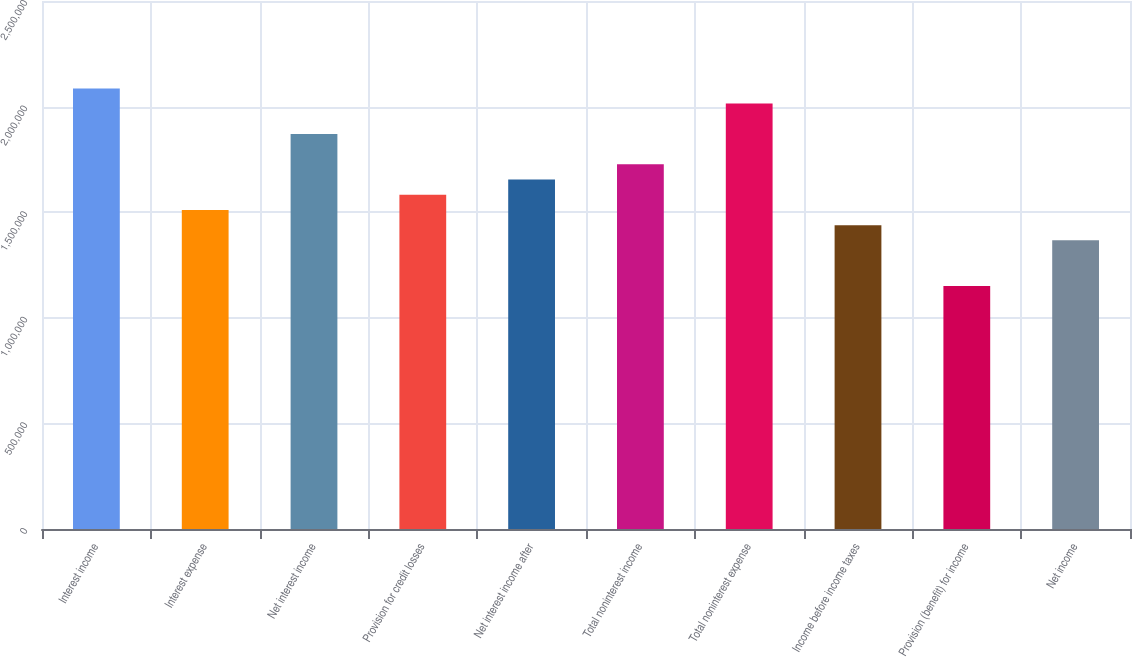Convert chart to OTSL. <chart><loc_0><loc_0><loc_500><loc_500><bar_chart><fcel>Interest income<fcel>Interest expense<fcel>Net interest income<fcel>Provision for credit losses<fcel>Net interest income after<fcel>Total noninterest income<fcel>Total noninterest expense<fcel>Income before income taxes<fcel>Provision (benefit) for income<fcel>Net income<nl><fcel>2.08622e+06<fcel>1.51071e+06<fcel>1.87041e+06<fcel>1.58265e+06<fcel>1.65459e+06<fcel>1.72653e+06<fcel>2.01428e+06<fcel>1.43877e+06<fcel>1.15102e+06<fcel>1.36684e+06<nl></chart> 